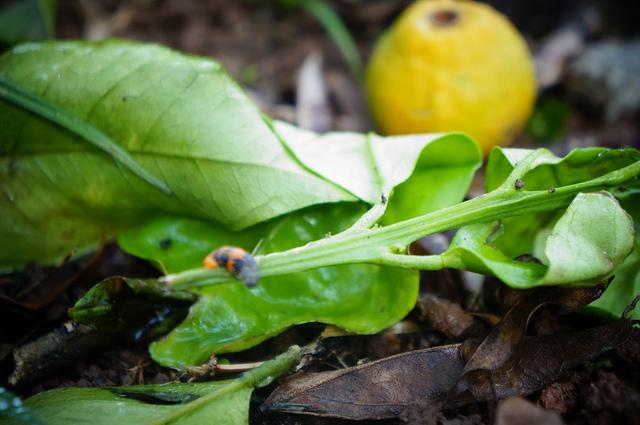What is the fruit?
Keep it brief. Lemon. What kind of fruit is shown?
Quick response, please. Lemon. What kind of animal is shown?
Short answer required. Caterpillar. What colors are the bug in the picture?
Answer briefly. Orange and black. What color is the fruit in the background?
Give a very brief answer. Yellow. 